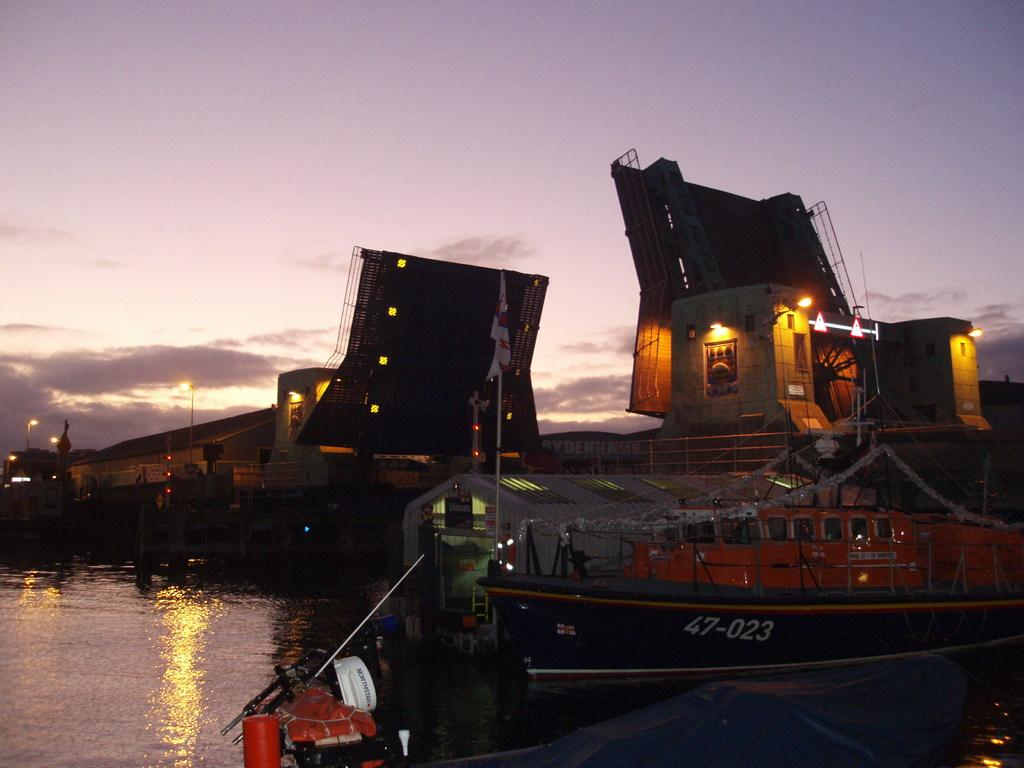What type of vehicles are in the image? There are boats in the image. What is the primary setting for the boats in the image? There is water visible at the bottom of the image. What is visible at the top of the image? The sky is visible at the top of the image. How many clams can be seen on the boats in the image? There are no clams visible on the boats in the image. Are there any boys playing near the river in the image? There is no river or boys present in the image; it features boats on water. 